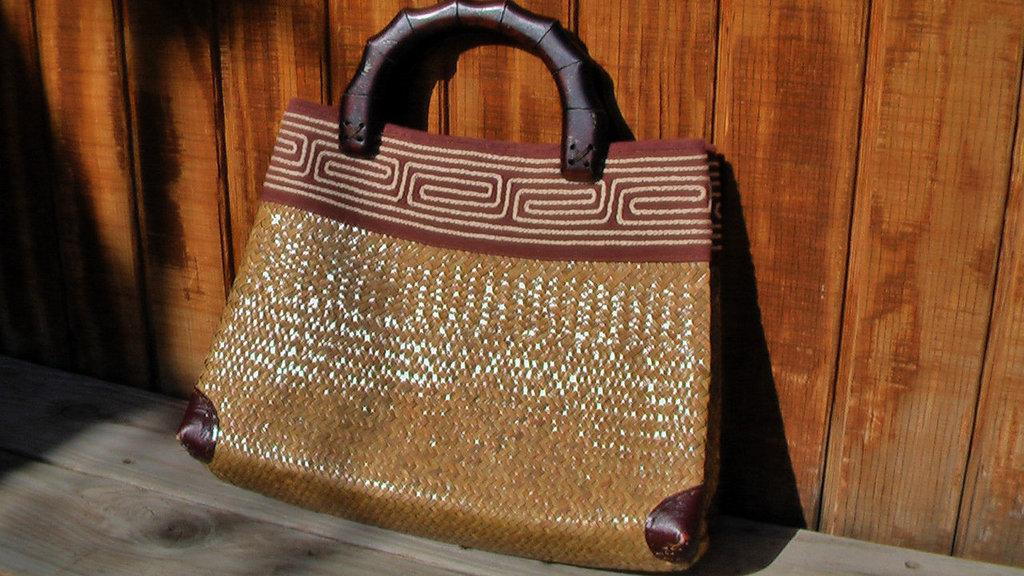What object is visible in the image? There is a handbag in the image. Where is the handbag located? The handbag is placed on a wooden board. How many cats are sitting on the handbag in the image? There are no cats present in the image. What type of journey is the handbag taking in the image? The handbag is not taking any journey in the image; it is stationary on the wooden board. 